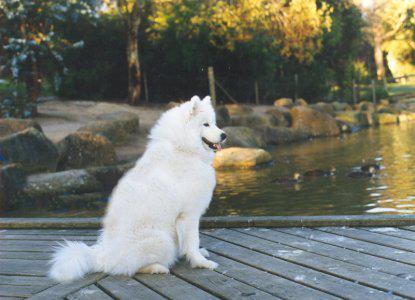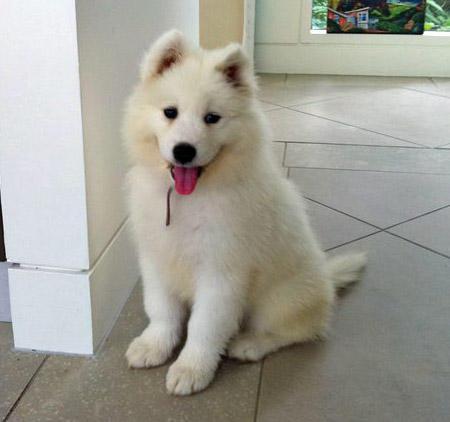The first image is the image on the left, the second image is the image on the right. Analyze the images presented: Is the assertion "There is a white dog facing the right with trees in the background." valid? Answer yes or no. Yes. The first image is the image on the left, the second image is the image on the right. Given the left and right images, does the statement "In one image, three white dogs are with a person." hold true? Answer yes or no. No. The first image is the image on the left, the second image is the image on the right. For the images displayed, is the sentence "A person is visible behind three white dogs in one image." factually correct? Answer yes or no. No. 